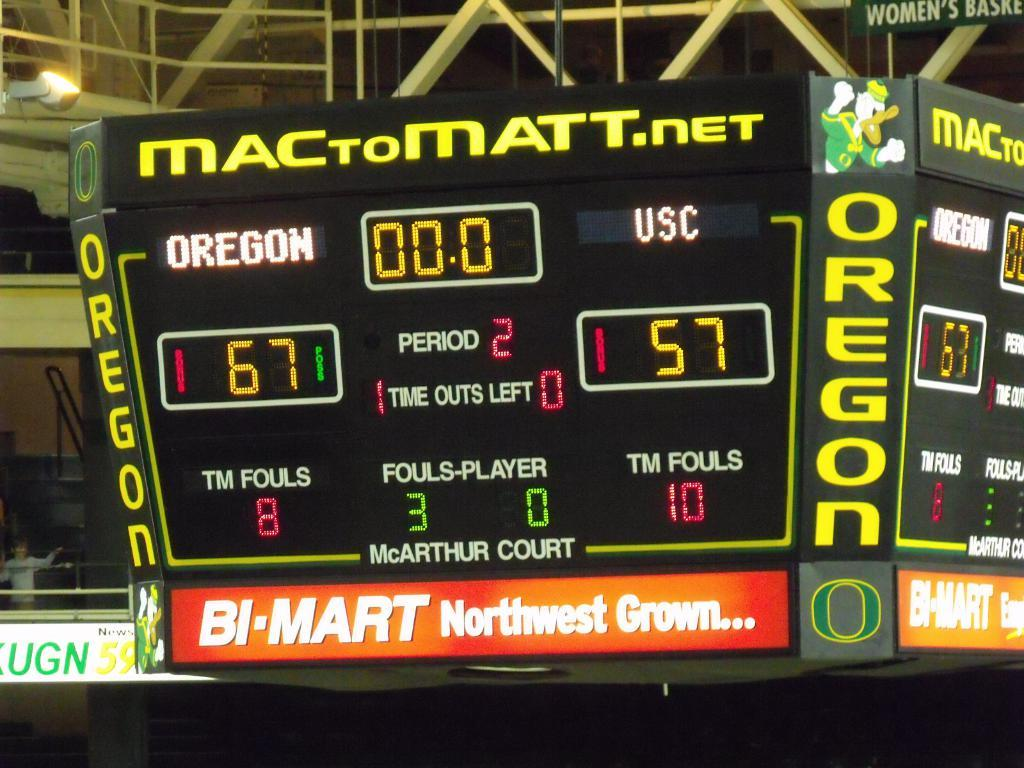<image>
Give a short and clear explanation of the subsequent image. Large scoreboard showing the score currently at 67-57. 